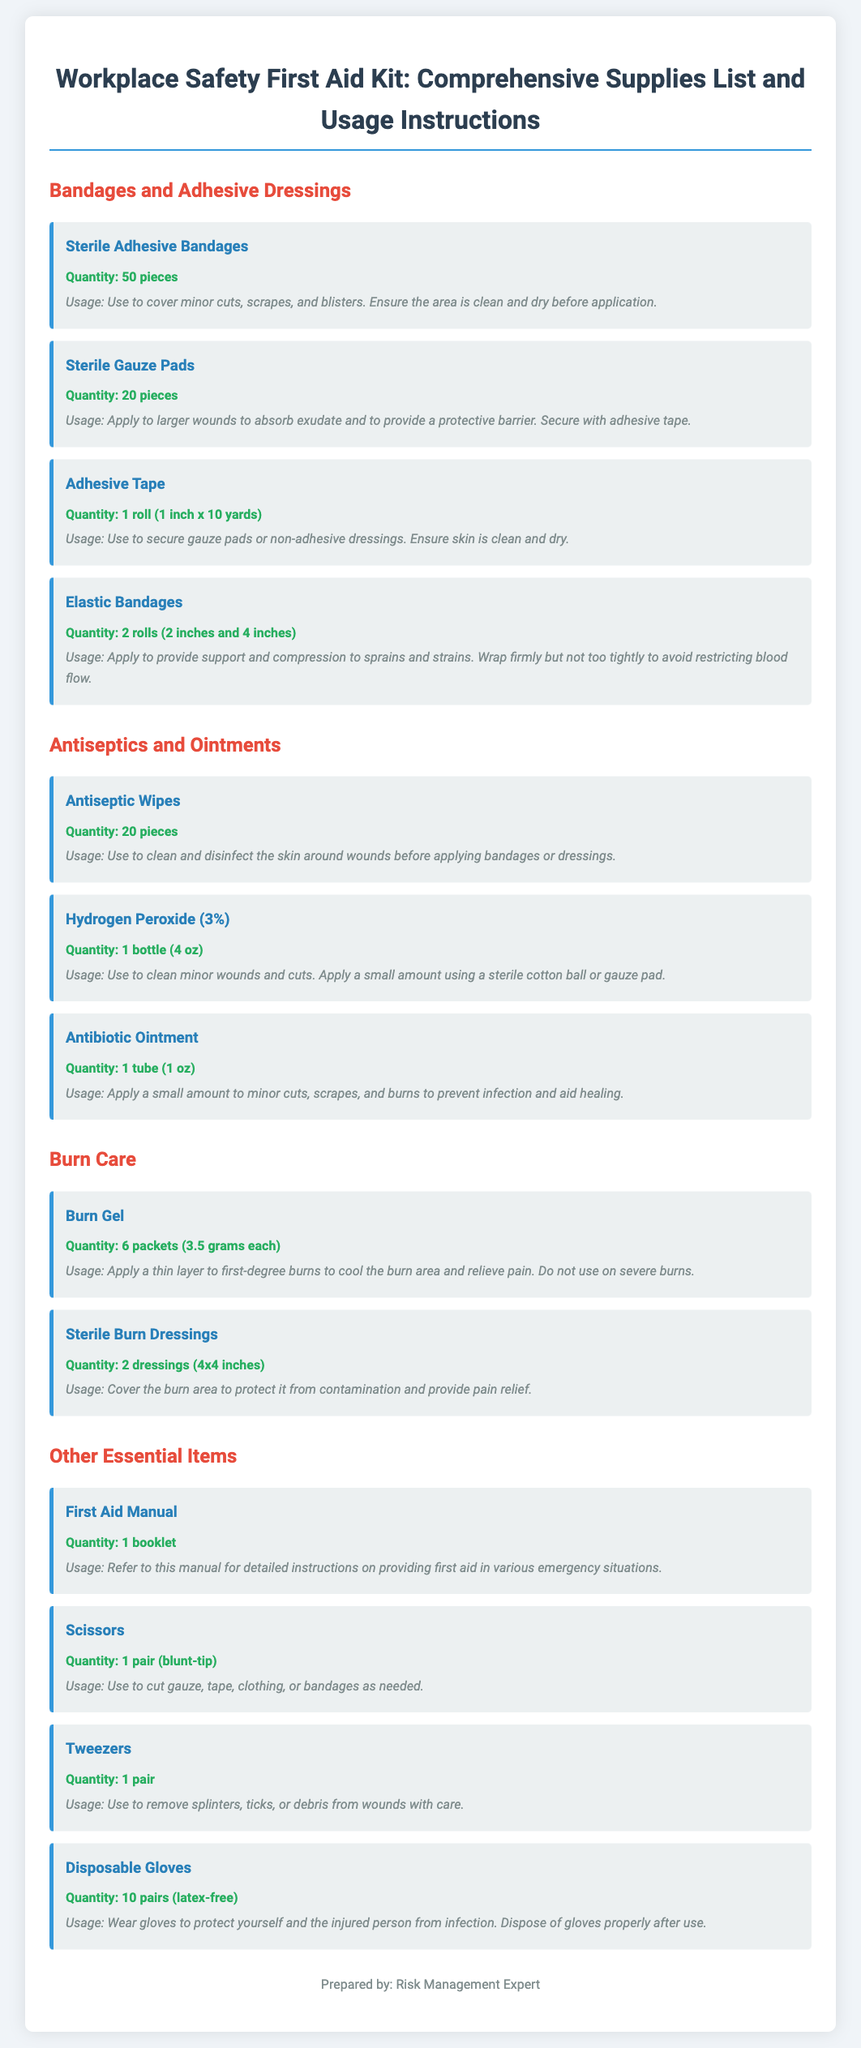What is the title of the document? The title of the document is found at the top and summarizes the contents.
Answer: Workplace Safety First Aid Kit: Comprehensive Supplies List and Usage Instructions How many sterile adhesive bandages are listed? The quantity of sterile adhesive bandages is specifically mentioned in the first section of the document.
Answer: 50 pieces What type of burn care items are included? The document mentions specific burn care items required for treating burns.
Answer: Burn Gel and Sterile Burn Dressings What is the quantity of antiseptic wipes? It is directly stated in the Antiseptics and Ointments section.
Answer: 20 pieces What is the purpose of the first aid manual? The document explains the role of the first aid manual within the first aid kit.
Answer: Detailed instructions for providing first aid What should you do before applying a sterile adhesive bandage? This is stated in the usage instructions for sterile adhesive bandages.
Answer: Ensure the area is clean and dry What is the purpose of disposable gloves? The document details the purpose of disposable gloves in the context of first aid.
Answer: Protect from infection How many rolls of elastic bandages are included? The quantity of elastic bandages is specified in the packing list.
Answer: 2 rolls What size are the sterile burn dressings? The dimensions are mentioned in the burn care section of the document.
Answer: 4x4 inches 